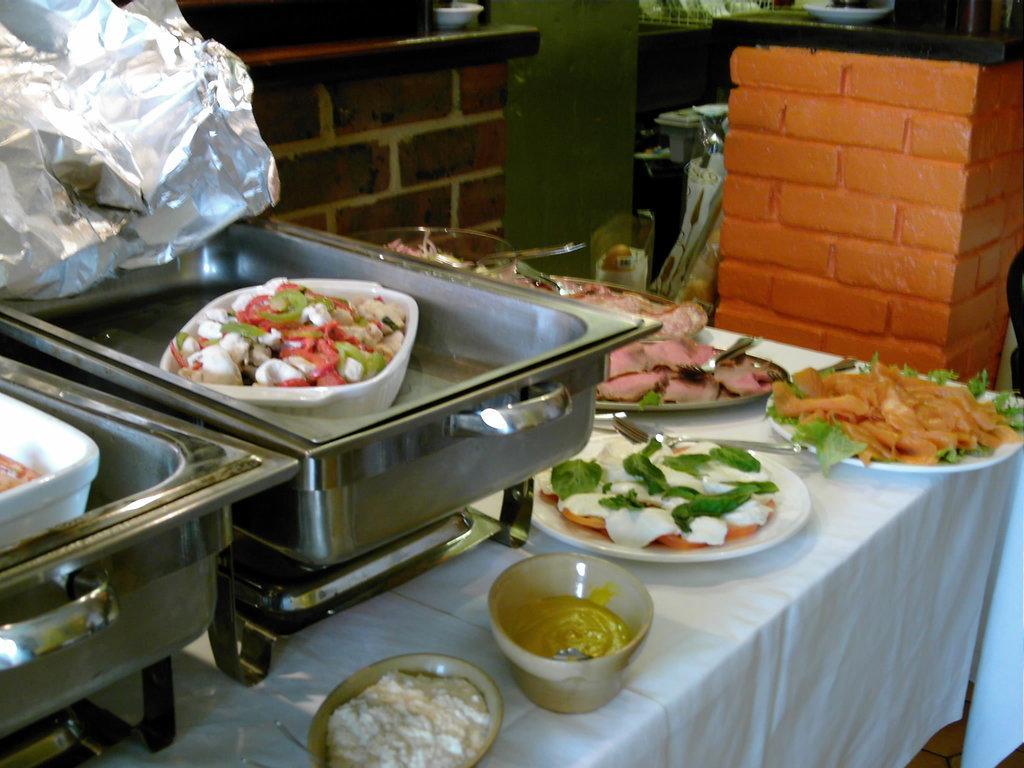Could you give a brief overview of what you see in this image? To the bottom of the image there is a table with white cloth. On the table to the left side there are steel trays with white color bowls with food items in it. Above the steel tray there is a silver foil. On the table there are bowls and plates with food items and also there are spoon and forks. Behind the table to the right side of the image there is a pillar with bricks and bowl on it. Behind the table to the left side there is a brick wall. 